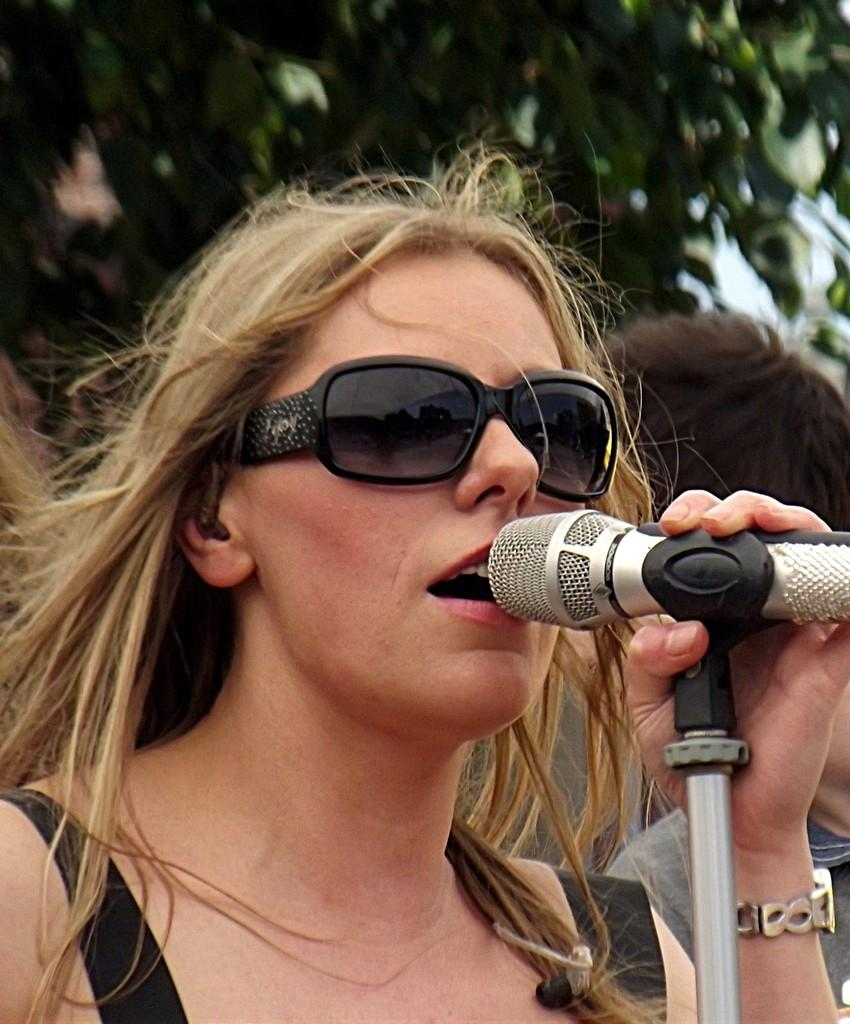What is the main subject of the image? There is a lady in the image. What is the lady holding in her hand? The lady is holding a microphone in her left hand. What type of bear can be seen interacting with the lady in the image? There is no bear present in the image; the lady is holding a microphone in her left hand. What type of growth is visible on the lady's face in the image? There is no growth visible on the lady's face in the image. 